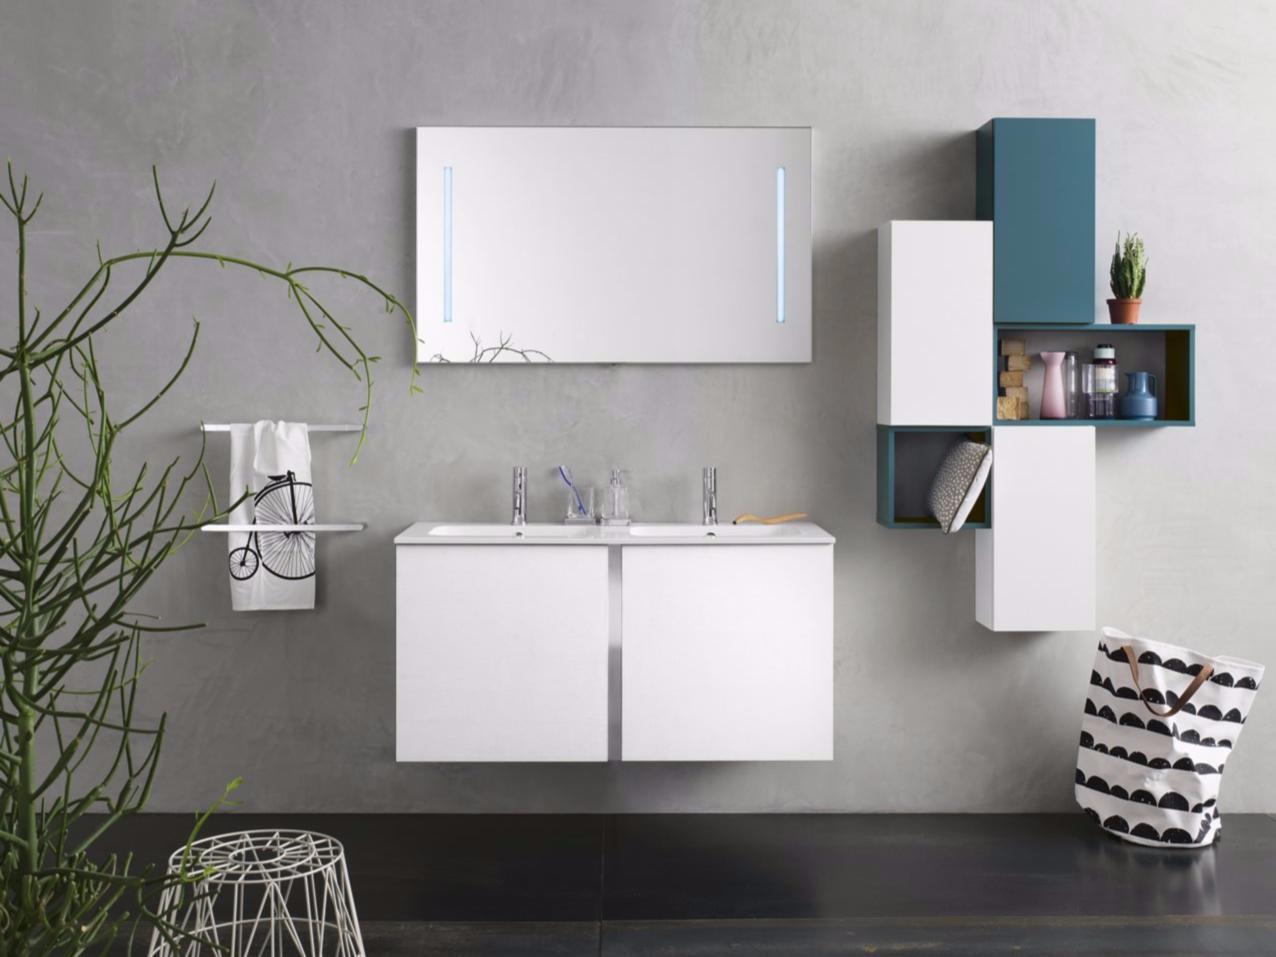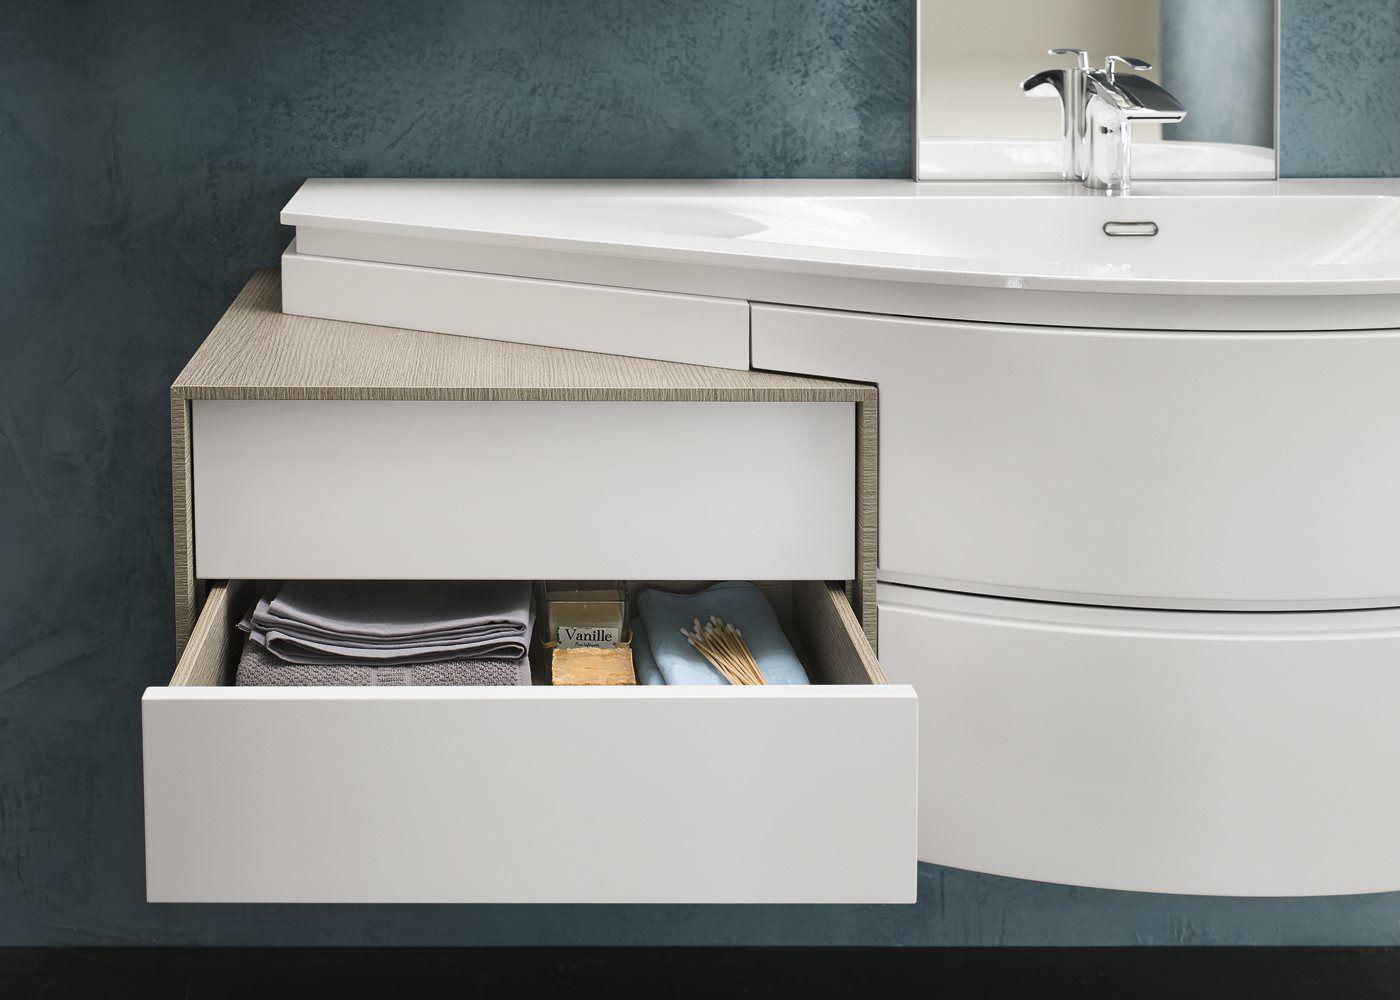The first image is the image on the left, the second image is the image on the right. Assess this claim about the two images: "IN at least one image there is a single raised basin on top of a floating cabinet shelf.". Correct or not? Answer yes or no. No. 